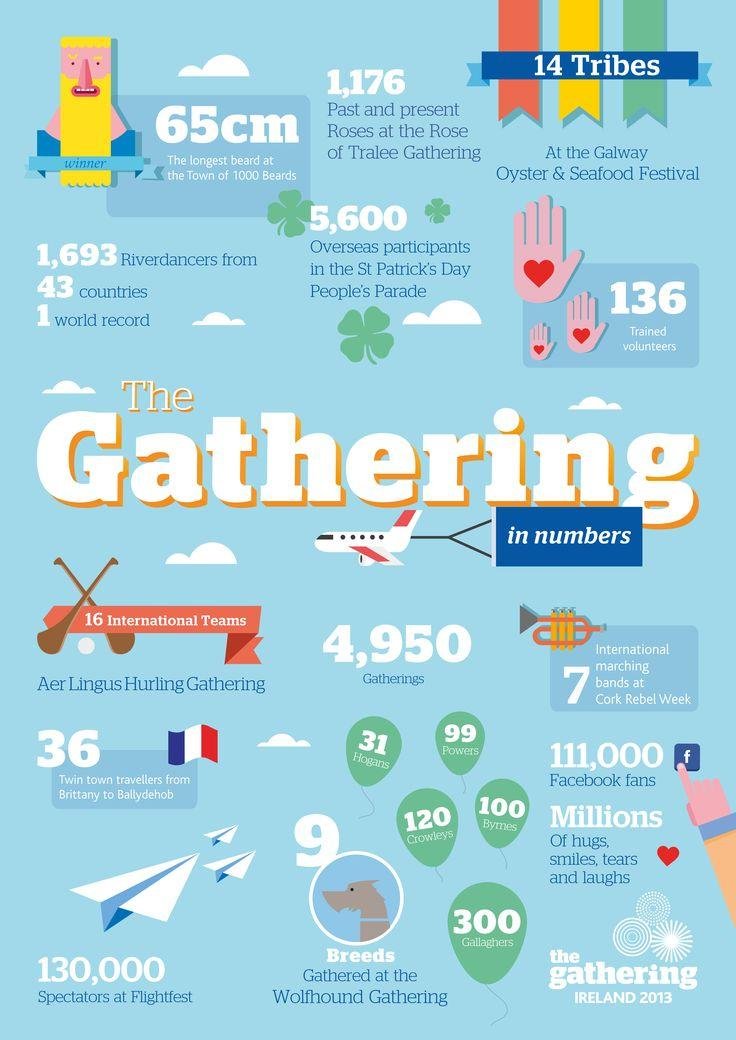Highlight a few significant elements in this photo. A variety of dogs had come to the gathering, with a total of 9 in total. 